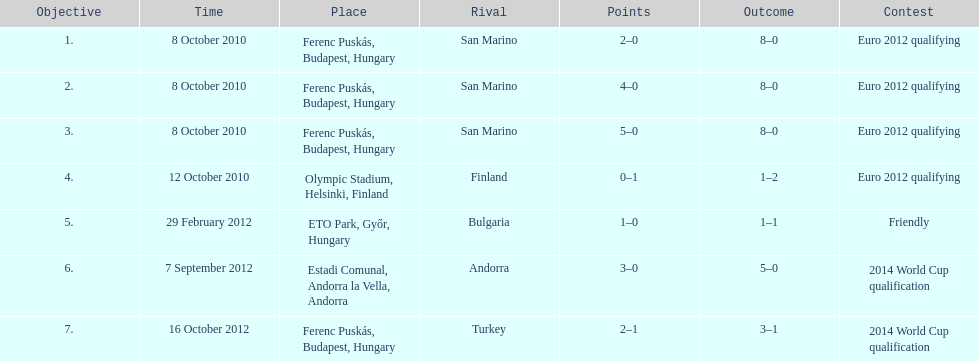Szalai scored all but one of his international goals in either euro 2012 qualifying or what other level of play? 2014 World Cup qualification. 